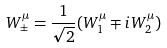Convert formula to latex. <formula><loc_0><loc_0><loc_500><loc_500>W _ { \pm } ^ { \mu } = \frac { 1 } { \sqrt { 2 } } ( W _ { 1 } ^ { \mu } \mp i W _ { 2 } ^ { \mu } )</formula> 